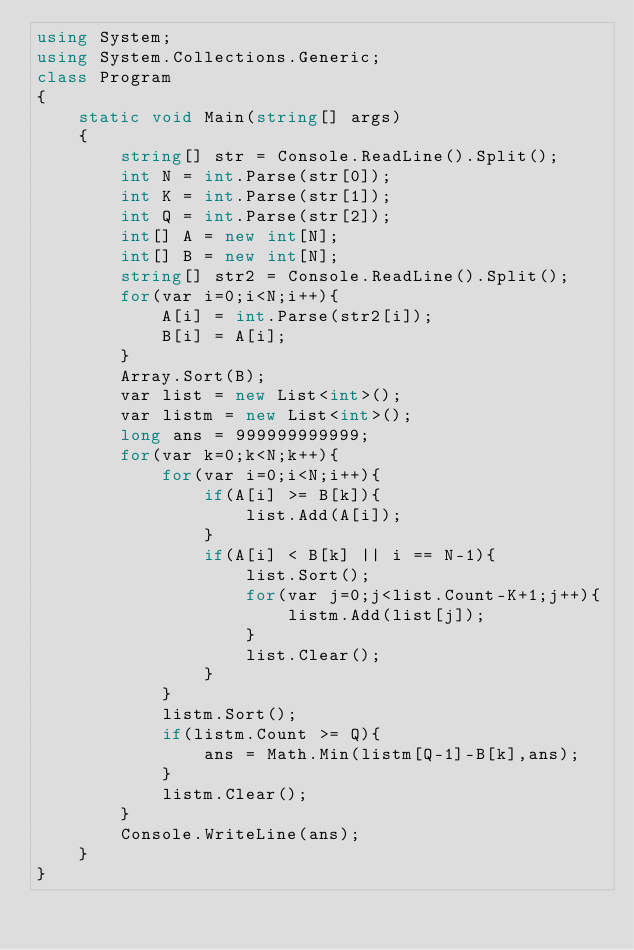<code> <loc_0><loc_0><loc_500><loc_500><_C#_>using System;
using System.Collections.Generic;
class Program
{
	static void Main(string[] args)
	{
		string[] str = Console.ReadLine().Split();
		int N = int.Parse(str[0]);
		int K = int.Parse(str[1]);
		int Q = int.Parse(str[2]);
		int[] A = new int[N];
		int[] B = new int[N];
		string[] str2 = Console.ReadLine().Split();
		for(var i=0;i<N;i++){
			A[i] = int.Parse(str2[i]);
			B[i] = A[i];
		}
		Array.Sort(B);
		var list = new List<int>();
		var listm = new List<int>();
		long ans = 999999999999;
		for(var k=0;k<N;k++){
			for(var i=0;i<N;i++){
				if(A[i] >= B[k]){
					list.Add(A[i]);
				}
				if(A[i] < B[k] || i == N-1){
					list.Sort();
					for(var j=0;j<list.Count-K+1;j++){
						listm.Add(list[j]);
					}
					list.Clear();
				}
			}
			listm.Sort();
			if(listm.Count >= Q){
				ans = Math.Min(listm[Q-1]-B[k],ans);
			}
			listm.Clear();
		}
		Console.WriteLine(ans);
	}
}</code> 